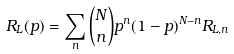<formula> <loc_0><loc_0><loc_500><loc_500>R _ { L } ( p ) = \sum _ { n } { N \choose n } p ^ { n } ( 1 - p ) ^ { N - n } R _ { L , n }</formula> 